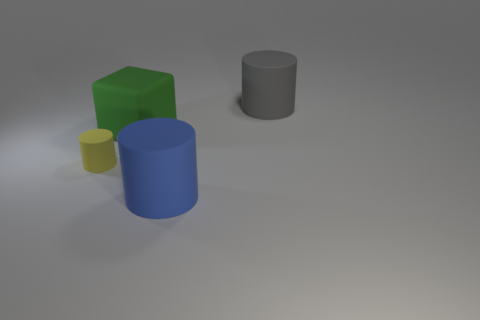Can you describe the lighting in the scene? The lighting in the scene is diffused with a gentle gradient of shadowing, indicating a soft overhead light source with minimal harshness or direct spotlighting. 